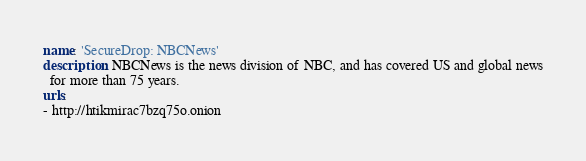<code> <loc_0><loc_0><loc_500><loc_500><_YAML_>name: 'SecureDrop: NBCNews'
description: NBCNews is the news division of NBC, and has covered US and global news
  for more than 75 years.
urls:
- http://htikmirac7bzq75o.onion
</code> 